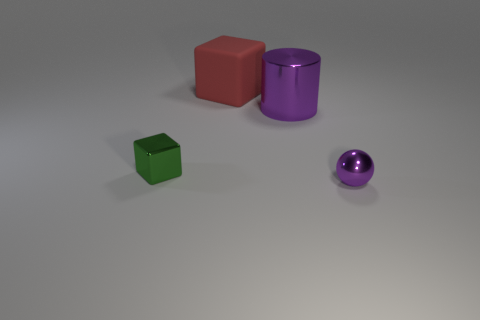Is the color of the tiny object that is to the right of the large purple thing the same as the metal cylinder?
Offer a very short reply. Yes. Is the size of the green cube the same as the purple sphere?
Offer a terse response. Yes. What is the shape of the object that is the same size as the green shiny block?
Offer a very short reply. Sphere. Is the size of the shiny object on the left side of the rubber cube the same as the small metal ball?
Your response must be concise. Yes. There is a thing that is the same size as the red block; what is it made of?
Your response must be concise. Metal. Is there a metallic cylinder that is to the right of the small metallic object on the left side of the small metal thing that is in front of the green object?
Offer a very short reply. Yes. Is there any other thing that has the same shape as the small purple object?
Offer a terse response. No. There is a large thing in front of the red thing; does it have the same color as the tiny thing right of the green block?
Offer a terse response. Yes. Are any small green rubber blocks visible?
Provide a succinct answer. No. There is a tiny object that is the same color as the large shiny cylinder; what material is it?
Your response must be concise. Metal. 